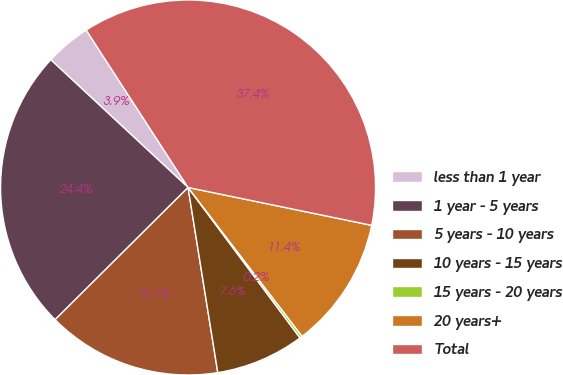Convert chart to OTSL. <chart><loc_0><loc_0><loc_500><loc_500><pie_chart><fcel>less than 1 year<fcel>1 year - 5 years<fcel>5 years - 10 years<fcel>10 years - 15 years<fcel>15 years - 20 years<fcel>20 years+<fcel>Total<nl><fcel>3.93%<fcel>24.38%<fcel>15.08%<fcel>7.65%<fcel>0.22%<fcel>11.36%<fcel>37.38%<nl></chart> 